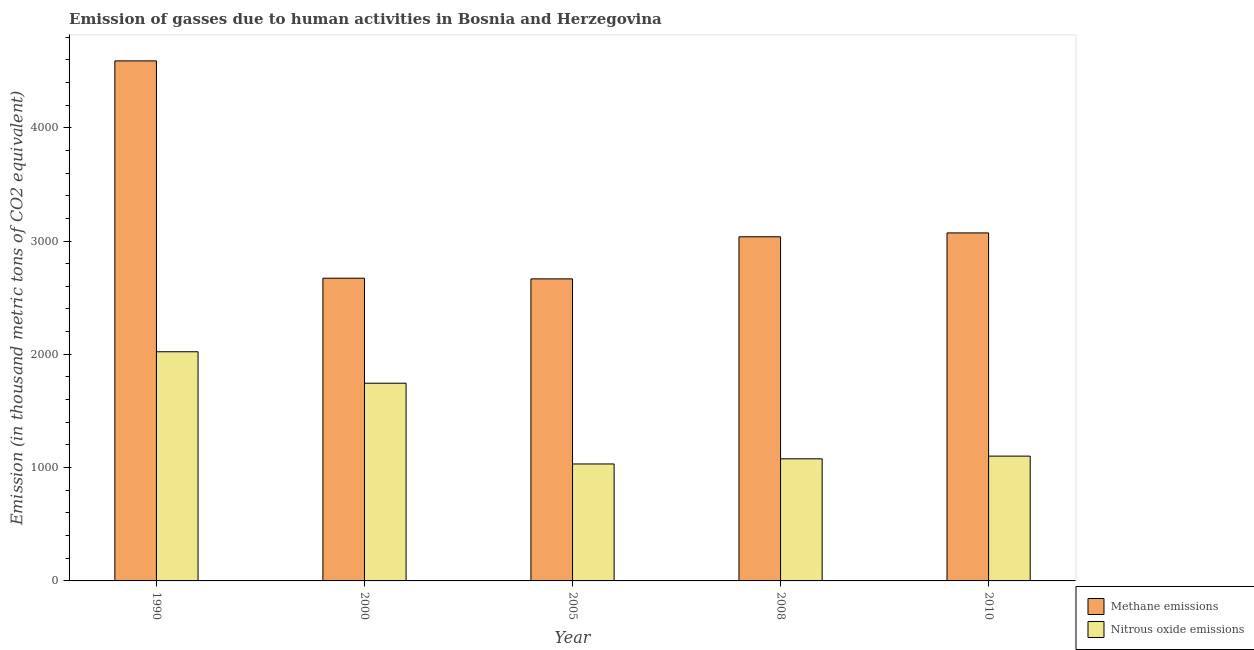How many different coloured bars are there?
Your response must be concise. 2. Are the number of bars per tick equal to the number of legend labels?
Offer a very short reply. Yes. What is the label of the 5th group of bars from the left?
Your answer should be compact. 2010. What is the amount of methane emissions in 2000?
Keep it short and to the point. 2671.7. Across all years, what is the maximum amount of methane emissions?
Your answer should be very brief. 4589.8. Across all years, what is the minimum amount of nitrous oxide emissions?
Your answer should be compact. 1032.3. In which year was the amount of methane emissions maximum?
Offer a very short reply. 1990. What is the total amount of nitrous oxide emissions in the graph?
Keep it short and to the point. 6978.9. What is the difference between the amount of methane emissions in 2008 and that in 2010?
Keep it short and to the point. -34. What is the difference between the amount of nitrous oxide emissions in 2000 and the amount of methane emissions in 2010?
Your answer should be compact. 643.4. What is the average amount of nitrous oxide emissions per year?
Provide a succinct answer. 1395.78. In the year 2005, what is the difference between the amount of nitrous oxide emissions and amount of methane emissions?
Your answer should be very brief. 0. In how many years, is the amount of nitrous oxide emissions greater than 3800 thousand metric tons?
Your answer should be compact. 0. What is the ratio of the amount of methane emissions in 1990 to that in 2005?
Your answer should be compact. 1.72. What is the difference between the highest and the second highest amount of nitrous oxide emissions?
Offer a very short reply. 277.7. What is the difference between the highest and the lowest amount of methane emissions?
Ensure brevity in your answer.  1924.1. Is the sum of the amount of nitrous oxide emissions in 1990 and 2000 greater than the maximum amount of methane emissions across all years?
Provide a succinct answer. Yes. What does the 2nd bar from the left in 1990 represents?
Provide a short and direct response. Nitrous oxide emissions. What does the 2nd bar from the right in 2010 represents?
Your answer should be very brief. Methane emissions. What is the difference between two consecutive major ticks on the Y-axis?
Offer a very short reply. 1000. Are the values on the major ticks of Y-axis written in scientific E-notation?
Keep it short and to the point. No. What is the title of the graph?
Keep it short and to the point. Emission of gasses due to human activities in Bosnia and Herzegovina. Does "Merchandise imports" appear as one of the legend labels in the graph?
Ensure brevity in your answer.  No. What is the label or title of the Y-axis?
Your response must be concise. Emission (in thousand metric tons of CO2 equivalent). What is the Emission (in thousand metric tons of CO2 equivalent) in Methane emissions in 1990?
Keep it short and to the point. 4589.8. What is the Emission (in thousand metric tons of CO2 equivalent) of Nitrous oxide emissions in 1990?
Offer a terse response. 2022.6. What is the Emission (in thousand metric tons of CO2 equivalent) in Methane emissions in 2000?
Your answer should be compact. 2671.7. What is the Emission (in thousand metric tons of CO2 equivalent) of Nitrous oxide emissions in 2000?
Offer a very short reply. 1744.9. What is the Emission (in thousand metric tons of CO2 equivalent) in Methane emissions in 2005?
Ensure brevity in your answer.  2665.7. What is the Emission (in thousand metric tons of CO2 equivalent) in Nitrous oxide emissions in 2005?
Give a very brief answer. 1032.3. What is the Emission (in thousand metric tons of CO2 equivalent) in Methane emissions in 2008?
Provide a succinct answer. 3037.4. What is the Emission (in thousand metric tons of CO2 equivalent) in Nitrous oxide emissions in 2008?
Give a very brief answer. 1077.6. What is the Emission (in thousand metric tons of CO2 equivalent) in Methane emissions in 2010?
Ensure brevity in your answer.  3071.4. What is the Emission (in thousand metric tons of CO2 equivalent) of Nitrous oxide emissions in 2010?
Keep it short and to the point. 1101.5. Across all years, what is the maximum Emission (in thousand metric tons of CO2 equivalent) of Methane emissions?
Keep it short and to the point. 4589.8. Across all years, what is the maximum Emission (in thousand metric tons of CO2 equivalent) of Nitrous oxide emissions?
Offer a very short reply. 2022.6. Across all years, what is the minimum Emission (in thousand metric tons of CO2 equivalent) of Methane emissions?
Make the answer very short. 2665.7. Across all years, what is the minimum Emission (in thousand metric tons of CO2 equivalent) in Nitrous oxide emissions?
Make the answer very short. 1032.3. What is the total Emission (in thousand metric tons of CO2 equivalent) of Methane emissions in the graph?
Provide a succinct answer. 1.60e+04. What is the total Emission (in thousand metric tons of CO2 equivalent) of Nitrous oxide emissions in the graph?
Ensure brevity in your answer.  6978.9. What is the difference between the Emission (in thousand metric tons of CO2 equivalent) in Methane emissions in 1990 and that in 2000?
Ensure brevity in your answer.  1918.1. What is the difference between the Emission (in thousand metric tons of CO2 equivalent) in Nitrous oxide emissions in 1990 and that in 2000?
Provide a short and direct response. 277.7. What is the difference between the Emission (in thousand metric tons of CO2 equivalent) in Methane emissions in 1990 and that in 2005?
Give a very brief answer. 1924.1. What is the difference between the Emission (in thousand metric tons of CO2 equivalent) in Nitrous oxide emissions in 1990 and that in 2005?
Offer a terse response. 990.3. What is the difference between the Emission (in thousand metric tons of CO2 equivalent) in Methane emissions in 1990 and that in 2008?
Provide a succinct answer. 1552.4. What is the difference between the Emission (in thousand metric tons of CO2 equivalent) in Nitrous oxide emissions in 1990 and that in 2008?
Your response must be concise. 945. What is the difference between the Emission (in thousand metric tons of CO2 equivalent) of Methane emissions in 1990 and that in 2010?
Your answer should be very brief. 1518.4. What is the difference between the Emission (in thousand metric tons of CO2 equivalent) of Nitrous oxide emissions in 1990 and that in 2010?
Give a very brief answer. 921.1. What is the difference between the Emission (in thousand metric tons of CO2 equivalent) in Nitrous oxide emissions in 2000 and that in 2005?
Ensure brevity in your answer.  712.6. What is the difference between the Emission (in thousand metric tons of CO2 equivalent) of Methane emissions in 2000 and that in 2008?
Offer a terse response. -365.7. What is the difference between the Emission (in thousand metric tons of CO2 equivalent) in Nitrous oxide emissions in 2000 and that in 2008?
Ensure brevity in your answer.  667.3. What is the difference between the Emission (in thousand metric tons of CO2 equivalent) of Methane emissions in 2000 and that in 2010?
Make the answer very short. -399.7. What is the difference between the Emission (in thousand metric tons of CO2 equivalent) in Nitrous oxide emissions in 2000 and that in 2010?
Your answer should be compact. 643.4. What is the difference between the Emission (in thousand metric tons of CO2 equivalent) of Methane emissions in 2005 and that in 2008?
Provide a succinct answer. -371.7. What is the difference between the Emission (in thousand metric tons of CO2 equivalent) of Nitrous oxide emissions in 2005 and that in 2008?
Offer a terse response. -45.3. What is the difference between the Emission (in thousand metric tons of CO2 equivalent) in Methane emissions in 2005 and that in 2010?
Your answer should be compact. -405.7. What is the difference between the Emission (in thousand metric tons of CO2 equivalent) of Nitrous oxide emissions in 2005 and that in 2010?
Your response must be concise. -69.2. What is the difference between the Emission (in thousand metric tons of CO2 equivalent) of Methane emissions in 2008 and that in 2010?
Keep it short and to the point. -34. What is the difference between the Emission (in thousand metric tons of CO2 equivalent) of Nitrous oxide emissions in 2008 and that in 2010?
Give a very brief answer. -23.9. What is the difference between the Emission (in thousand metric tons of CO2 equivalent) of Methane emissions in 1990 and the Emission (in thousand metric tons of CO2 equivalent) of Nitrous oxide emissions in 2000?
Ensure brevity in your answer.  2844.9. What is the difference between the Emission (in thousand metric tons of CO2 equivalent) in Methane emissions in 1990 and the Emission (in thousand metric tons of CO2 equivalent) in Nitrous oxide emissions in 2005?
Your answer should be very brief. 3557.5. What is the difference between the Emission (in thousand metric tons of CO2 equivalent) in Methane emissions in 1990 and the Emission (in thousand metric tons of CO2 equivalent) in Nitrous oxide emissions in 2008?
Make the answer very short. 3512.2. What is the difference between the Emission (in thousand metric tons of CO2 equivalent) of Methane emissions in 1990 and the Emission (in thousand metric tons of CO2 equivalent) of Nitrous oxide emissions in 2010?
Offer a very short reply. 3488.3. What is the difference between the Emission (in thousand metric tons of CO2 equivalent) of Methane emissions in 2000 and the Emission (in thousand metric tons of CO2 equivalent) of Nitrous oxide emissions in 2005?
Give a very brief answer. 1639.4. What is the difference between the Emission (in thousand metric tons of CO2 equivalent) in Methane emissions in 2000 and the Emission (in thousand metric tons of CO2 equivalent) in Nitrous oxide emissions in 2008?
Offer a very short reply. 1594.1. What is the difference between the Emission (in thousand metric tons of CO2 equivalent) in Methane emissions in 2000 and the Emission (in thousand metric tons of CO2 equivalent) in Nitrous oxide emissions in 2010?
Your response must be concise. 1570.2. What is the difference between the Emission (in thousand metric tons of CO2 equivalent) of Methane emissions in 2005 and the Emission (in thousand metric tons of CO2 equivalent) of Nitrous oxide emissions in 2008?
Keep it short and to the point. 1588.1. What is the difference between the Emission (in thousand metric tons of CO2 equivalent) in Methane emissions in 2005 and the Emission (in thousand metric tons of CO2 equivalent) in Nitrous oxide emissions in 2010?
Provide a succinct answer. 1564.2. What is the difference between the Emission (in thousand metric tons of CO2 equivalent) in Methane emissions in 2008 and the Emission (in thousand metric tons of CO2 equivalent) in Nitrous oxide emissions in 2010?
Ensure brevity in your answer.  1935.9. What is the average Emission (in thousand metric tons of CO2 equivalent) in Methane emissions per year?
Ensure brevity in your answer.  3207.2. What is the average Emission (in thousand metric tons of CO2 equivalent) in Nitrous oxide emissions per year?
Your response must be concise. 1395.78. In the year 1990, what is the difference between the Emission (in thousand metric tons of CO2 equivalent) in Methane emissions and Emission (in thousand metric tons of CO2 equivalent) in Nitrous oxide emissions?
Offer a very short reply. 2567.2. In the year 2000, what is the difference between the Emission (in thousand metric tons of CO2 equivalent) of Methane emissions and Emission (in thousand metric tons of CO2 equivalent) of Nitrous oxide emissions?
Your response must be concise. 926.8. In the year 2005, what is the difference between the Emission (in thousand metric tons of CO2 equivalent) of Methane emissions and Emission (in thousand metric tons of CO2 equivalent) of Nitrous oxide emissions?
Your response must be concise. 1633.4. In the year 2008, what is the difference between the Emission (in thousand metric tons of CO2 equivalent) in Methane emissions and Emission (in thousand metric tons of CO2 equivalent) in Nitrous oxide emissions?
Your answer should be compact. 1959.8. In the year 2010, what is the difference between the Emission (in thousand metric tons of CO2 equivalent) in Methane emissions and Emission (in thousand metric tons of CO2 equivalent) in Nitrous oxide emissions?
Provide a succinct answer. 1969.9. What is the ratio of the Emission (in thousand metric tons of CO2 equivalent) of Methane emissions in 1990 to that in 2000?
Your answer should be compact. 1.72. What is the ratio of the Emission (in thousand metric tons of CO2 equivalent) of Nitrous oxide emissions in 1990 to that in 2000?
Keep it short and to the point. 1.16. What is the ratio of the Emission (in thousand metric tons of CO2 equivalent) of Methane emissions in 1990 to that in 2005?
Provide a succinct answer. 1.72. What is the ratio of the Emission (in thousand metric tons of CO2 equivalent) in Nitrous oxide emissions in 1990 to that in 2005?
Offer a very short reply. 1.96. What is the ratio of the Emission (in thousand metric tons of CO2 equivalent) of Methane emissions in 1990 to that in 2008?
Your answer should be very brief. 1.51. What is the ratio of the Emission (in thousand metric tons of CO2 equivalent) in Nitrous oxide emissions in 1990 to that in 2008?
Give a very brief answer. 1.88. What is the ratio of the Emission (in thousand metric tons of CO2 equivalent) in Methane emissions in 1990 to that in 2010?
Provide a short and direct response. 1.49. What is the ratio of the Emission (in thousand metric tons of CO2 equivalent) in Nitrous oxide emissions in 1990 to that in 2010?
Ensure brevity in your answer.  1.84. What is the ratio of the Emission (in thousand metric tons of CO2 equivalent) of Methane emissions in 2000 to that in 2005?
Ensure brevity in your answer.  1. What is the ratio of the Emission (in thousand metric tons of CO2 equivalent) in Nitrous oxide emissions in 2000 to that in 2005?
Offer a very short reply. 1.69. What is the ratio of the Emission (in thousand metric tons of CO2 equivalent) in Methane emissions in 2000 to that in 2008?
Make the answer very short. 0.88. What is the ratio of the Emission (in thousand metric tons of CO2 equivalent) in Nitrous oxide emissions in 2000 to that in 2008?
Give a very brief answer. 1.62. What is the ratio of the Emission (in thousand metric tons of CO2 equivalent) of Methane emissions in 2000 to that in 2010?
Offer a very short reply. 0.87. What is the ratio of the Emission (in thousand metric tons of CO2 equivalent) in Nitrous oxide emissions in 2000 to that in 2010?
Offer a very short reply. 1.58. What is the ratio of the Emission (in thousand metric tons of CO2 equivalent) in Methane emissions in 2005 to that in 2008?
Ensure brevity in your answer.  0.88. What is the ratio of the Emission (in thousand metric tons of CO2 equivalent) of Nitrous oxide emissions in 2005 to that in 2008?
Your response must be concise. 0.96. What is the ratio of the Emission (in thousand metric tons of CO2 equivalent) in Methane emissions in 2005 to that in 2010?
Offer a terse response. 0.87. What is the ratio of the Emission (in thousand metric tons of CO2 equivalent) in Nitrous oxide emissions in 2005 to that in 2010?
Provide a succinct answer. 0.94. What is the ratio of the Emission (in thousand metric tons of CO2 equivalent) in Methane emissions in 2008 to that in 2010?
Your answer should be compact. 0.99. What is the ratio of the Emission (in thousand metric tons of CO2 equivalent) of Nitrous oxide emissions in 2008 to that in 2010?
Ensure brevity in your answer.  0.98. What is the difference between the highest and the second highest Emission (in thousand metric tons of CO2 equivalent) in Methane emissions?
Your response must be concise. 1518.4. What is the difference between the highest and the second highest Emission (in thousand metric tons of CO2 equivalent) in Nitrous oxide emissions?
Give a very brief answer. 277.7. What is the difference between the highest and the lowest Emission (in thousand metric tons of CO2 equivalent) of Methane emissions?
Keep it short and to the point. 1924.1. What is the difference between the highest and the lowest Emission (in thousand metric tons of CO2 equivalent) in Nitrous oxide emissions?
Offer a very short reply. 990.3. 